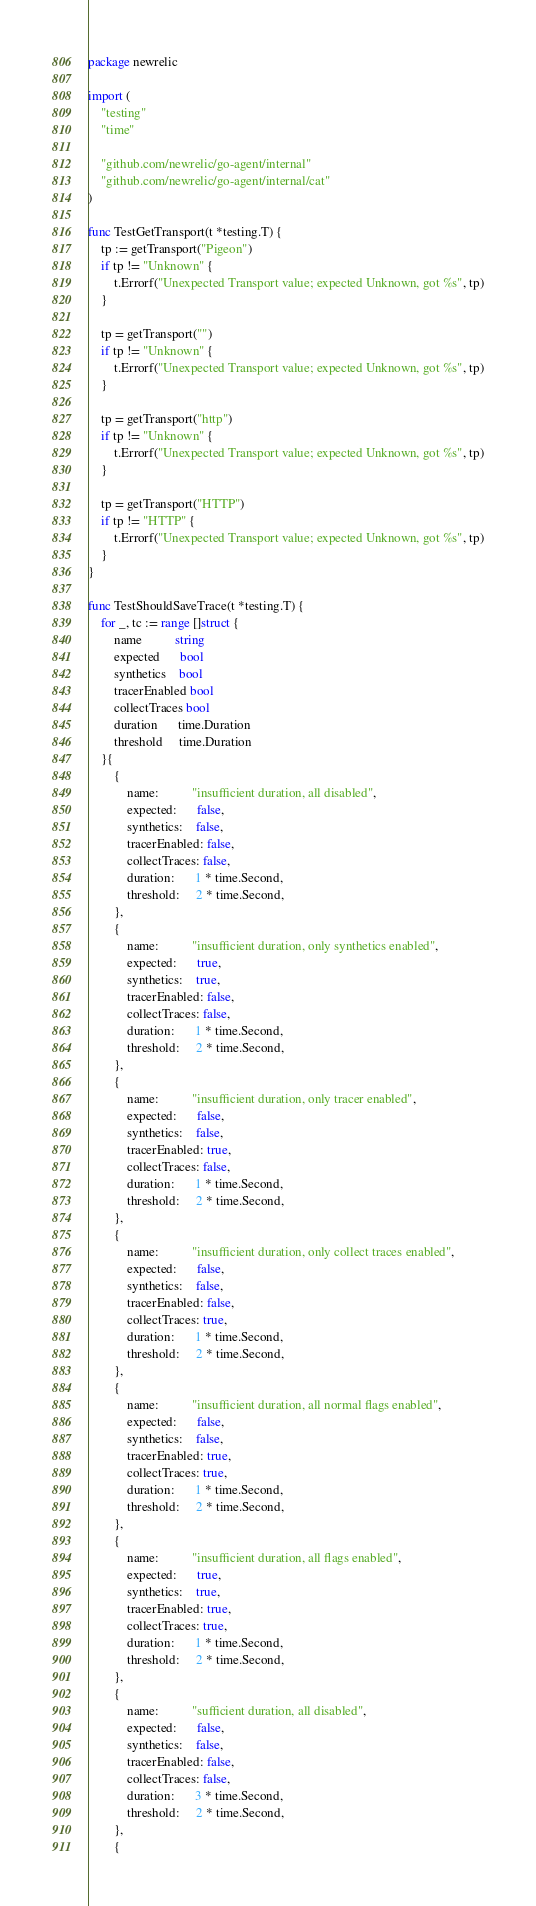Convert code to text. <code><loc_0><loc_0><loc_500><loc_500><_Go_>package newrelic

import (
	"testing"
	"time"

	"github.com/newrelic/go-agent/internal"
	"github.com/newrelic/go-agent/internal/cat"
)

func TestGetTransport(t *testing.T) {
	tp := getTransport("Pigeon")
	if tp != "Unknown" {
		t.Errorf("Unexpected Transport value; expected Unknown, got %s", tp)
	}

	tp = getTransport("")
	if tp != "Unknown" {
		t.Errorf("Unexpected Transport value; expected Unknown, got %s", tp)
	}

	tp = getTransport("http")
	if tp != "Unknown" {
		t.Errorf("Unexpected Transport value; expected Unknown, got %s", tp)
	}

	tp = getTransport("HTTP")
	if tp != "HTTP" {
		t.Errorf("Unexpected Transport value; expected Unknown, got %s", tp)
	}
}

func TestShouldSaveTrace(t *testing.T) {
	for _, tc := range []struct {
		name          string
		expected      bool
		synthetics    bool
		tracerEnabled bool
		collectTraces bool
		duration      time.Duration
		threshold     time.Duration
	}{
		{
			name:          "insufficient duration, all disabled",
			expected:      false,
			synthetics:    false,
			tracerEnabled: false,
			collectTraces: false,
			duration:      1 * time.Second,
			threshold:     2 * time.Second,
		},
		{
			name:          "insufficient duration, only synthetics enabled",
			expected:      true,
			synthetics:    true,
			tracerEnabled: false,
			collectTraces: false,
			duration:      1 * time.Second,
			threshold:     2 * time.Second,
		},
		{
			name:          "insufficient duration, only tracer enabled",
			expected:      false,
			synthetics:    false,
			tracerEnabled: true,
			collectTraces: false,
			duration:      1 * time.Second,
			threshold:     2 * time.Second,
		},
		{
			name:          "insufficient duration, only collect traces enabled",
			expected:      false,
			synthetics:    false,
			tracerEnabled: false,
			collectTraces: true,
			duration:      1 * time.Second,
			threshold:     2 * time.Second,
		},
		{
			name:          "insufficient duration, all normal flags enabled",
			expected:      false,
			synthetics:    false,
			tracerEnabled: true,
			collectTraces: true,
			duration:      1 * time.Second,
			threshold:     2 * time.Second,
		},
		{
			name:          "insufficient duration, all flags enabled",
			expected:      true,
			synthetics:    true,
			tracerEnabled: true,
			collectTraces: true,
			duration:      1 * time.Second,
			threshold:     2 * time.Second,
		},
		{
			name:          "sufficient duration, all disabled",
			expected:      false,
			synthetics:    false,
			tracerEnabled: false,
			collectTraces: false,
			duration:      3 * time.Second,
			threshold:     2 * time.Second,
		},
		{</code> 